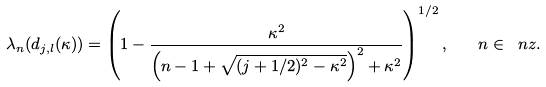Convert formula to latex. <formula><loc_0><loc_0><loc_500><loc_500>\lambda _ { n } ( d _ { j , l } ( \kappa ) ) = \left ( 1 - \frac { \kappa ^ { 2 } } { \left ( n - 1 + \sqrt { ( j + 1 / 2 ) ^ { 2 } - \kappa ^ { 2 } } \right ) ^ { 2 } + \kappa ^ { 2 } } \right ) ^ { 1 / 2 } , \quad n \in \ n z .</formula> 